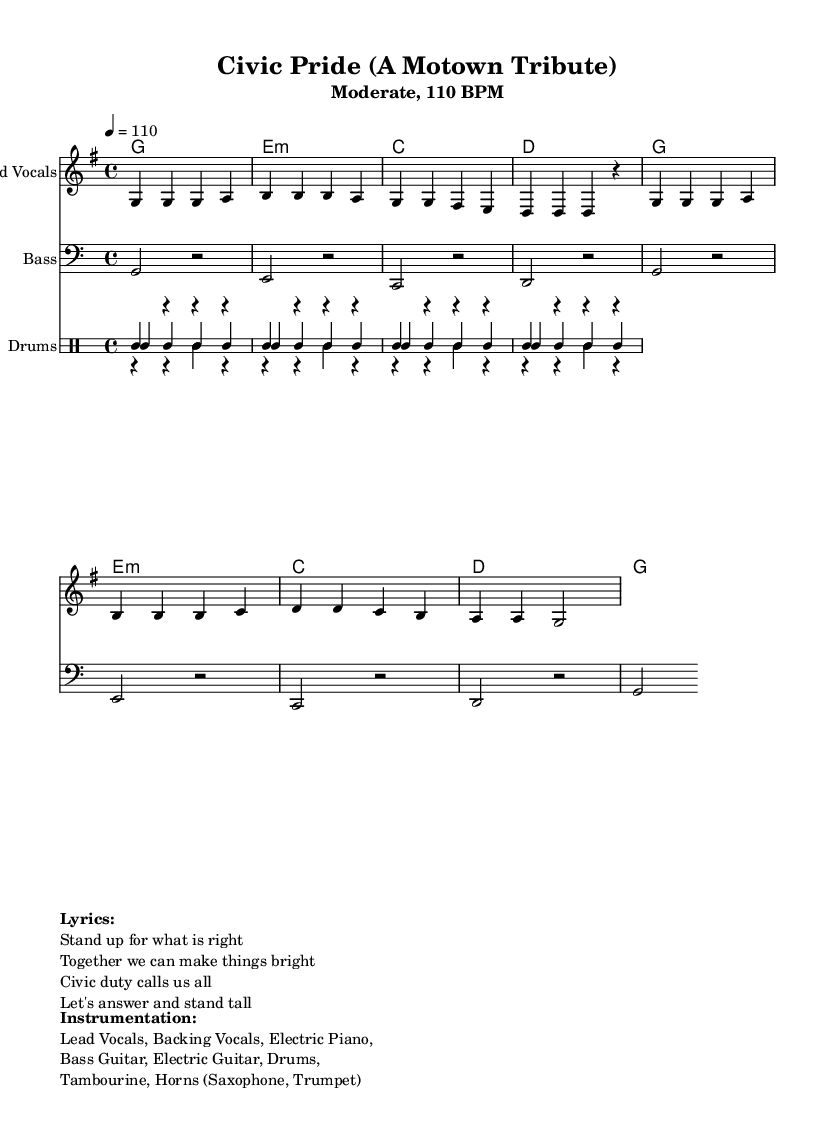What is the key signature of this music? The key signature is G major, which has one sharp (F#). This can be determined by analyzing the key signature indicated at the beginning of the score.
Answer: G major What is the time signature of this music? The time signature is 4/4, as indicated at the start of the score. This means there are four beats in each measure, and a quarter note gets one beat.
Answer: 4/4 What is the tempo marking for this piece? The tempo marking is 4 equals 110, which signifies the beats per minute. This indicates that the piece should be played at a moderate pace.
Answer: 110 BPM How many measures are present in the melody line? By counting the grouped notes in the melody part, there are eight measures in total across the provided section.
Answer: 8 What instruments are included in the instrumentation? The score lists Lead Vocals, Bass Guitar, Electric Piano, Electric Guitar, Drums, Tambourine, and Horns (Saxophone, Trumpet) as part of the instrumentation. This is detailed in the markup section under "Instrumentation."
Answer: Lead Vocals, Bass Guitar, Electric Piano, Electric Guitar, Drums, Tambourine, Horns How many times does the G note appear in the melody? The G note appears five times within the melody line as indicated by the notes written in the standard music notation. Counting the occurrences gives the correct total.
Answer: 5 Which chord follows the G major chord in the harmonies? The chord following the G major chord is E minor, as can be seen by looking at the sequence of chords listed in the harmony section, where the pattern is established.
Answer: E minor 